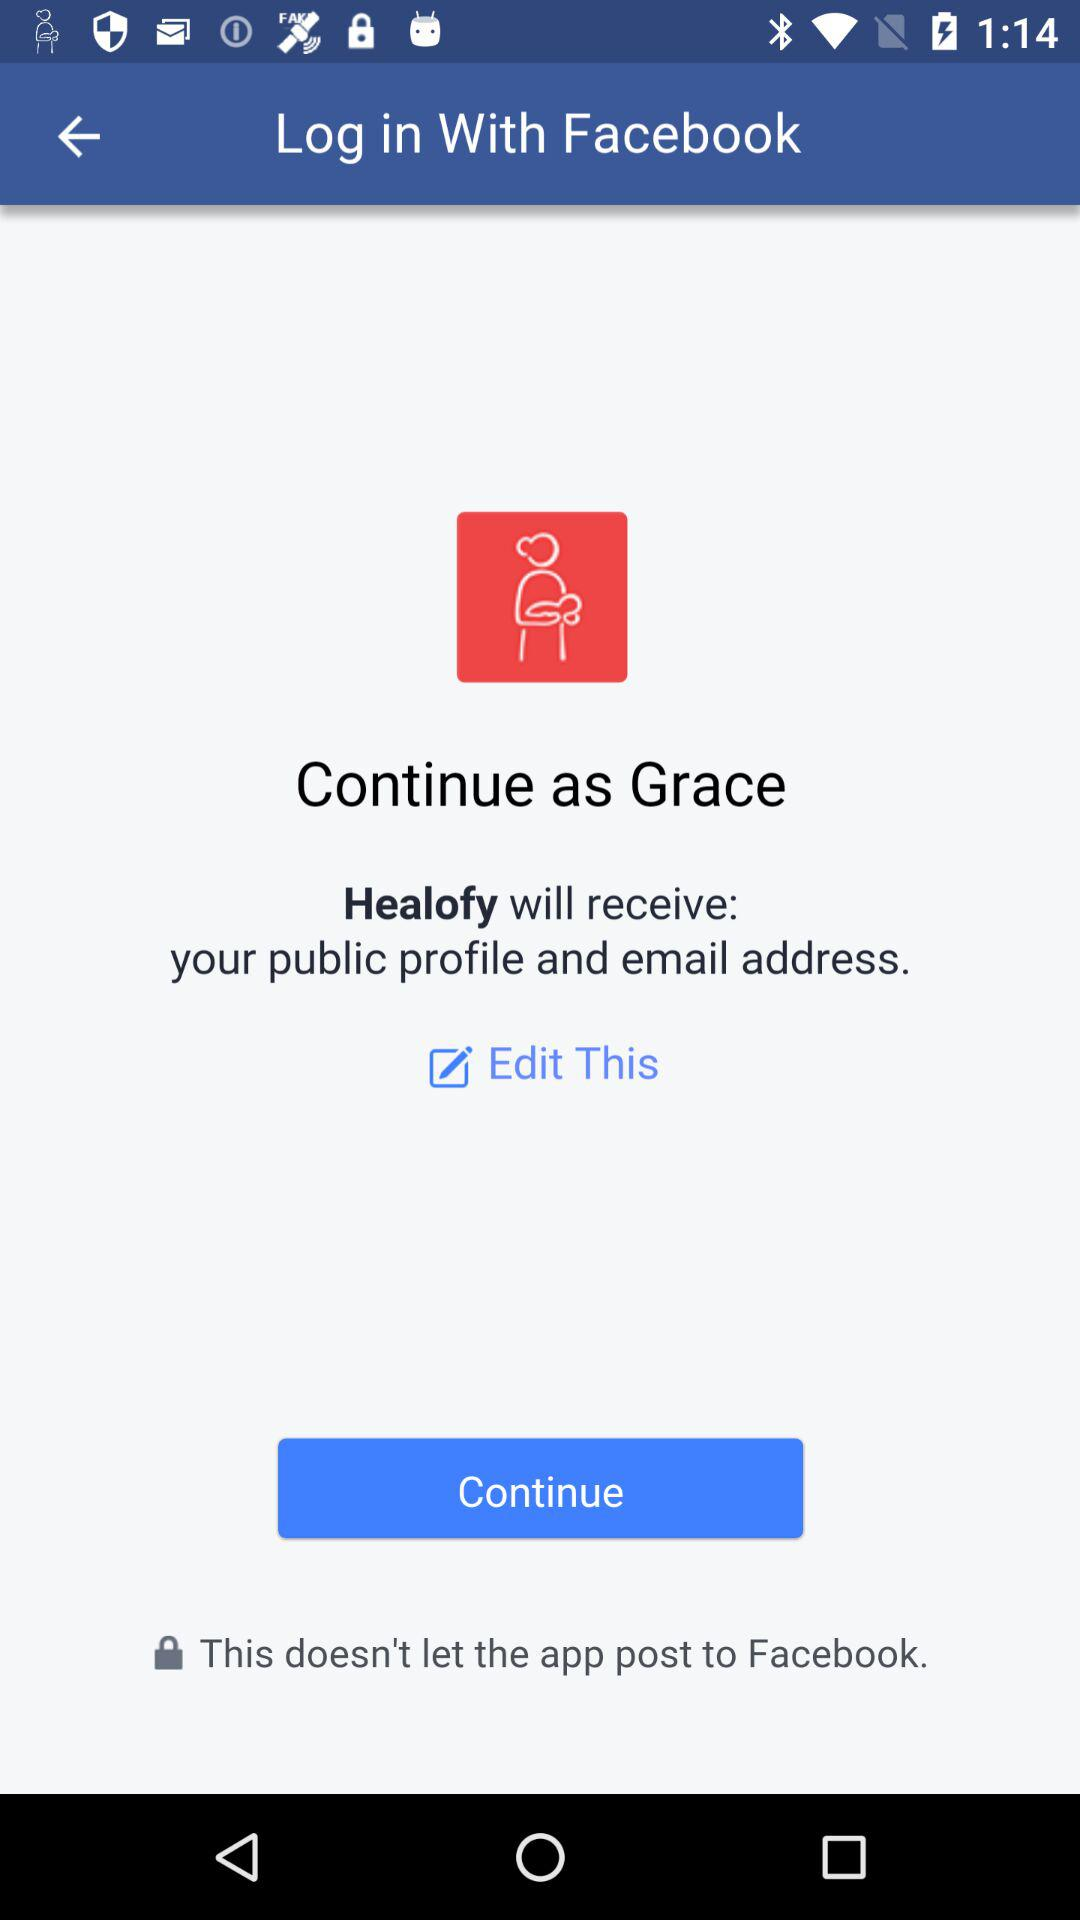What is the name of the user? The name of the user is Grace. 